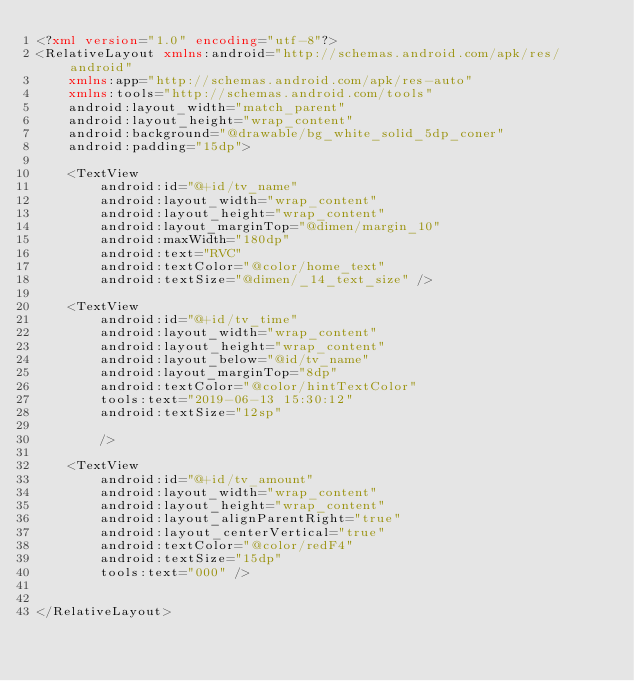<code> <loc_0><loc_0><loc_500><loc_500><_XML_><?xml version="1.0" encoding="utf-8"?>
<RelativeLayout xmlns:android="http://schemas.android.com/apk/res/android"
    xmlns:app="http://schemas.android.com/apk/res-auto"
    xmlns:tools="http://schemas.android.com/tools"
    android:layout_width="match_parent"
    android:layout_height="wrap_content"
    android:background="@drawable/bg_white_solid_5dp_coner"
    android:padding="15dp">

    <TextView
        android:id="@+id/tv_name"
        android:layout_width="wrap_content"
        android:layout_height="wrap_content"
        android:layout_marginTop="@dimen/margin_10"
        android:maxWidth="180dp"
        android:text="RVC"
        android:textColor="@color/home_text"
        android:textSize="@dimen/_14_text_size" />

    <TextView
        android:id="@+id/tv_time"
        android:layout_width="wrap_content"
        android:layout_height="wrap_content"
        android:layout_below="@id/tv_name"
        android:layout_marginTop="8dp"
        android:textColor="@color/hintTextColor"
        tools:text="2019-06-13 15:30:12"
        android:textSize="12sp"

        />

    <TextView
        android:id="@+id/tv_amount"
        android:layout_width="wrap_content"
        android:layout_height="wrap_content"
        android:layout_alignParentRight="true"
        android:layout_centerVertical="true"
        android:textColor="@color/redF4"
        android:textSize="15dp"
        tools:text="000" />


</RelativeLayout></code> 